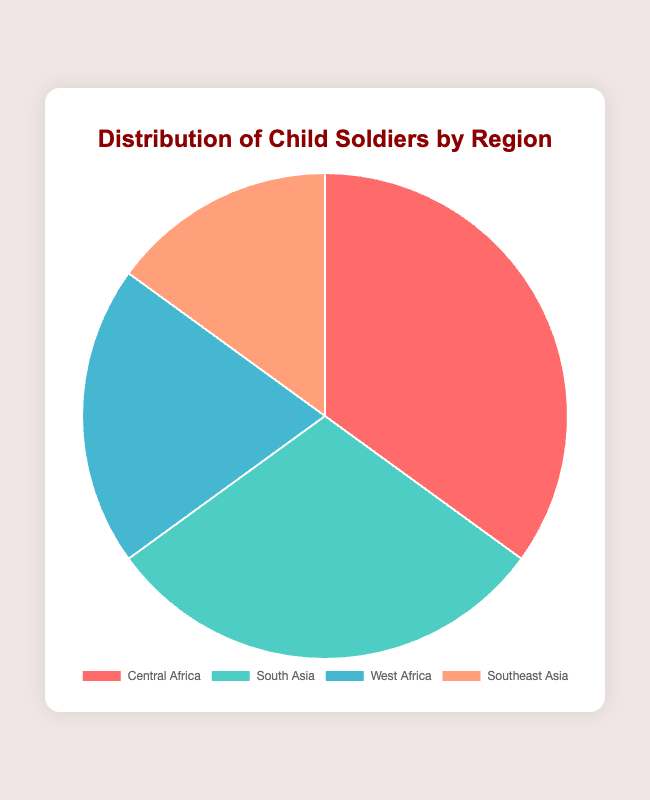What region has the highest percentage of child soldiers? By looking at the chart, we can see that Central Africa has the largest portion of the pie.
Answer: Central Africa Which region has the smallest percentage of child soldiers? The smallest segment of the pie chart corresponds to Southeast Asia.
Answer: Southeast Asia What is the percentage difference between Central Africa and Southeast Asia? Central Africa has 35% and Southeast Asia has 15%, so the difference is 35% - 15% = 20%.
Answer: 20% What two regions combined account for over half of the child soldiers? Central Africa has 35% and South Asia has 30%, together they sum to 35% + 30% = 65%, which is over half.
Answer: Central Africa and South Asia If we were to combine the percentages of West Africa and Southeast Asia, what would be the total? West Africa has 20% and Southeast Asia has 15%, so combined they account for 20% + 15% = 35%.
Answer: 35% Which region has a percentage that is closest to the average of all regions? The average percentage for 4 regions is (35% + 30% + 20% + 15%) / 4 = 25%. West Africa, with 20%, is the closest to this average.
Answer: West Africa By how many percentage points does South Asia exceed West Africa in terms of the proportion of child soldiers? South Asia has 30% and West Africa has 20%, so South Asia exceeds by 30% - 20% = 10%.
Answer: 10% What is the cumulative percentage of child soldiers in Africa (Central and West Africa together)? Central Africa has 35% and West Africa has 20%, so together they constitute 35% + 20% = 55%.
Answer: 55% If the percentage of child soldiers in Southeast Asia increased by 10 percentage points, how would it compare to the percentage in Central Africa? Currently, Southeast Asia has 15%, and increasing it by 10 percentage points gives 15% + 10% = 25%. Central Africa remains higher at 35%.
Answer: Central Africa would still be higher What are the colors used to represent the different regions in the pie chart? The colors in the chart are red for Central Africa, turquoise for South Asia, light blue for West Africa, and light orange for Southeast Asia.
Answer: Red, turquoise, light blue, light orange 